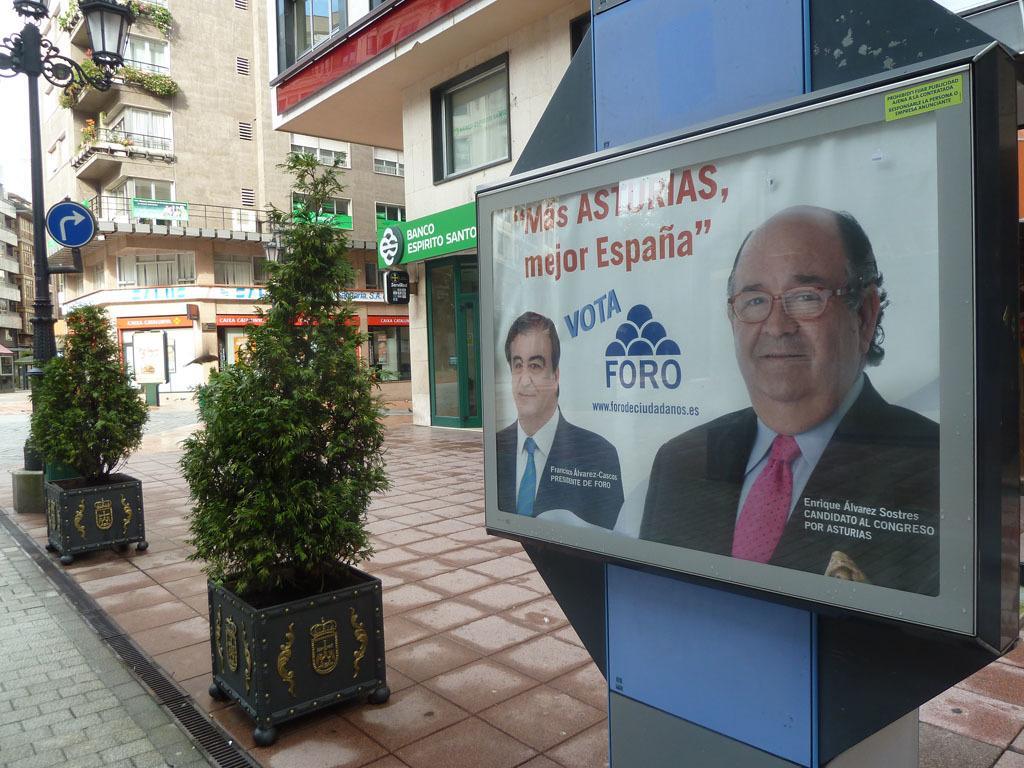Could you give a brief overview of what you see in this image? In this image we can see buildings, windows, there is a light pole, there is a sign board, plants, there are boards with text and images on it, also we can see the sky. 